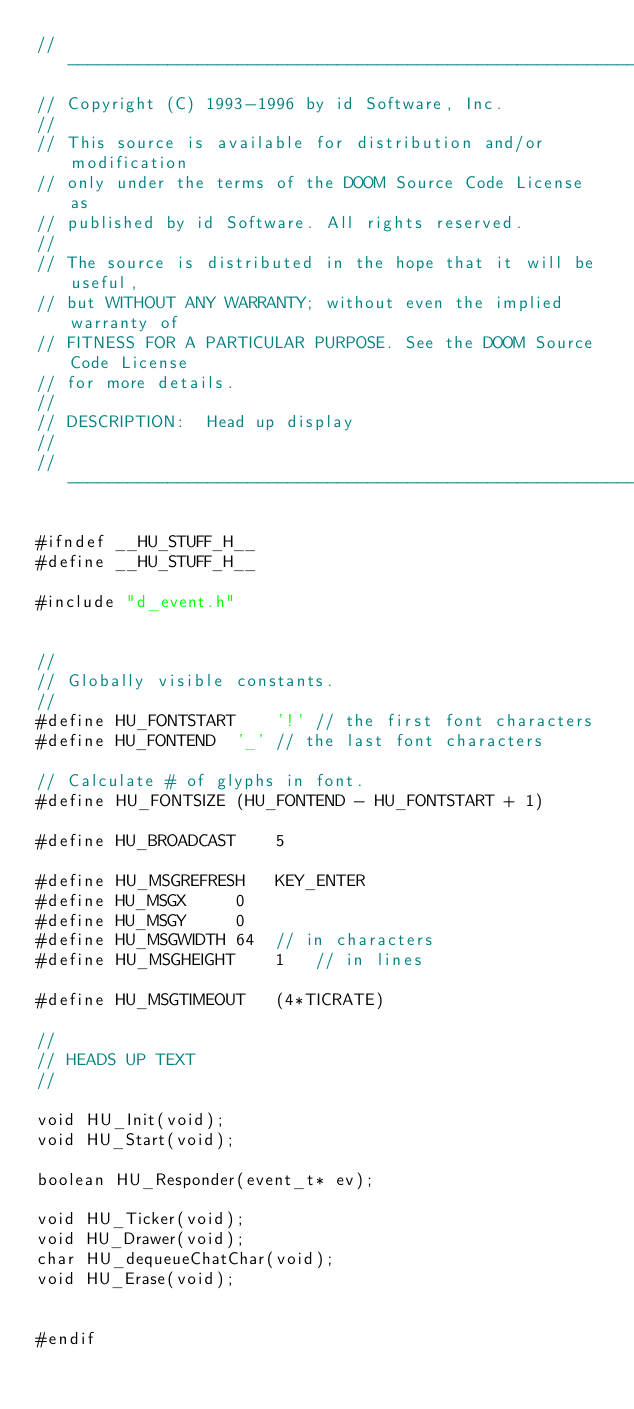<code> <loc_0><loc_0><loc_500><loc_500><_C_>//-----------------------------------------------------------------------------
// Copyright (C) 1993-1996 by id Software, Inc.
//
// This source is available for distribution and/or modification
// only under the terms of the DOOM Source Code License as
// published by id Software. All rights reserved.
//
// The source is distributed in the hope that it will be useful,
// but WITHOUT ANY WARRANTY; without even the implied warranty of
// FITNESS FOR A PARTICULAR PURPOSE. See the DOOM Source Code License
// for more details.
//
// DESCRIPTION:  Head up display
//
//-----------------------------------------------------------------------------

#ifndef __HU_STUFF_H__
#define __HU_STUFF_H__

#include "d_event.h"


//
// Globally visible constants.
//
#define HU_FONTSTART	'!'	// the first font characters
#define HU_FONTEND	'_'	// the last font characters

// Calculate # of glyphs in font.
#define HU_FONTSIZE	(HU_FONTEND - HU_FONTSTART + 1)	

#define HU_BROADCAST	5

#define HU_MSGREFRESH	KEY_ENTER
#define HU_MSGX		0
#define HU_MSGY		0
#define HU_MSGWIDTH	64	// in characters
#define HU_MSGHEIGHT	1	// in lines

#define HU_MSGTIMEOUT	(4*TICRATE)

//
// HEADS UP TEXT
//

void HU_Init(void);
void HU_Start(void);

boolean HU_Responder(event_t* ev);

void HU_Ticker(void);
void HU_Drawer(void);
char HU_dequeueChatChar(void);
void HU_Erase(void);


#endif
</code> 